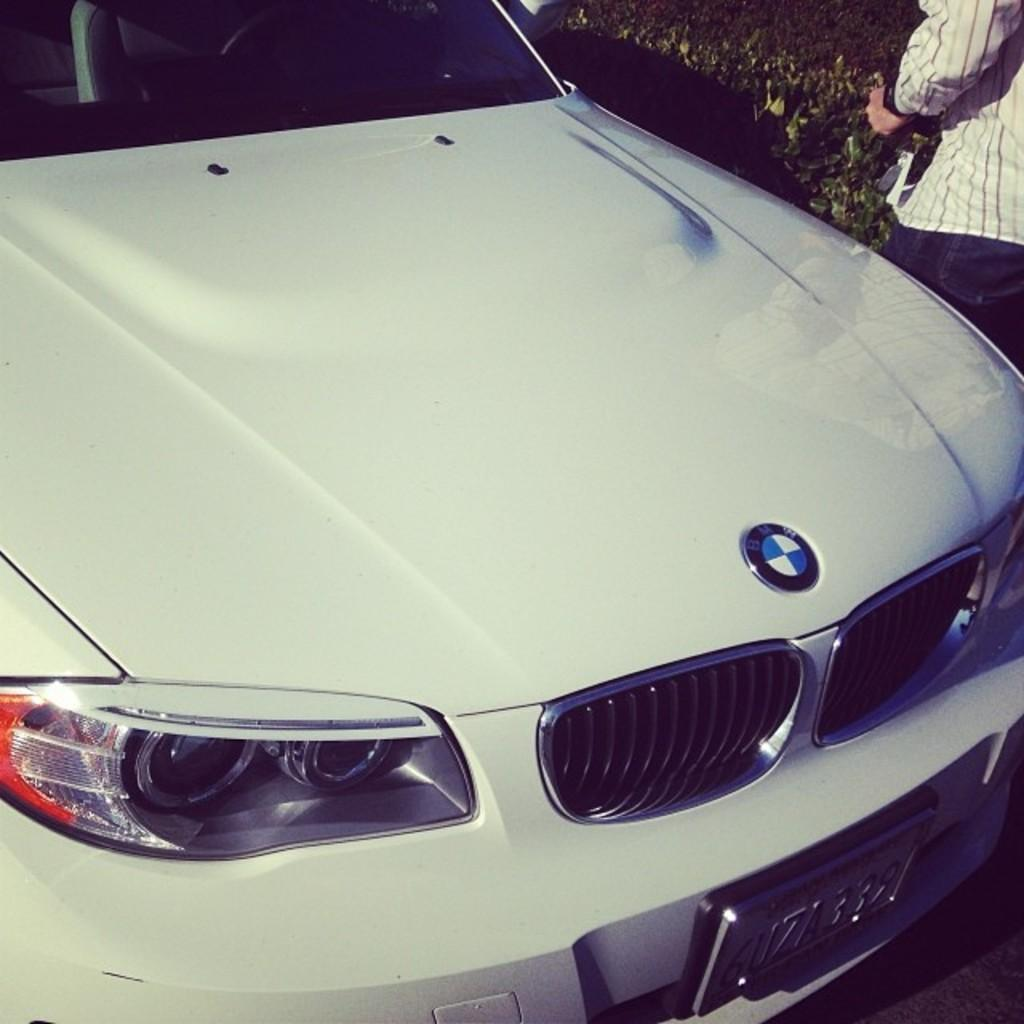What type of vehicle is on the road in the image? There is a car on the road in the image. Can you describe the person in the image? There is a person standing in the image. What type of vegetation is present in the image? There are bushes in the image. What type of spy equipment can be seen in the image? There is no spy equipment present in the image. What is the size of the jar in the image? There is no jar present in the image. 